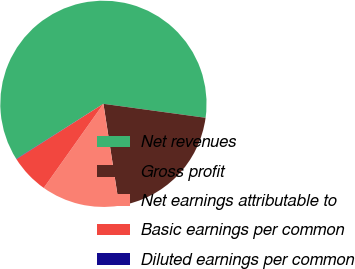Convert chart. <chart><loc_0><loc_0><loc_500><loc_500><pie_chart><fcel>Net revenues<fcel>Gross profit<fcel>Net earnings attributable to<fcel>Basic earnings per common<fcel>Diluted earnings per common<nl><fcel>61.13%<fcel>20.4%<fcel>12.26%<fcel>6.16%<fcel>0.05%<nl></chart> 